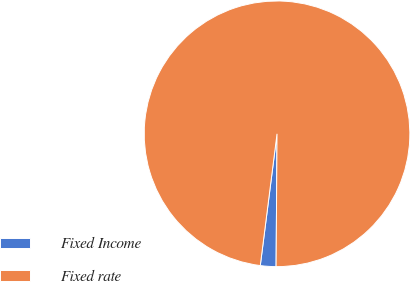Convert chart. <chart><loc_0><loc_0><loc_500><loc_500><pie_chart><fcel>Fixed Income<fcel>Fixed rate<nl><fcel>1.9%<fcel>98.1%<nl></chart> 